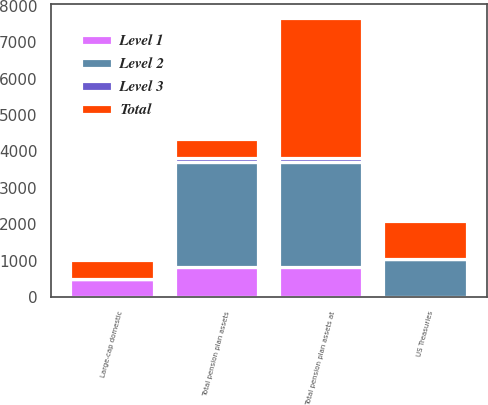Convert chart. <chart><loc_0><loc_0><loc_500><loc_500><stacked_bar_chart><ecel><fcel>US Treasuries<fcel>Large-cap domestic<fcel>Total pension plan assets at<fcel>Total pension plan assets<nl><fcel>Level 1<fcel>16<fcel>500<fcel>821<fcel>821<nl><fcel>Level 2<fcel>1029<fcel>11<fcel>2902<fcel>2902<nl><fcel>Level 3<fcel>3<fcel>1<fcel>107<fcel>107<nl><fcel>Total<fcel>1048<fcel>512<fcel>3830<fcel>512<nl></chart> 